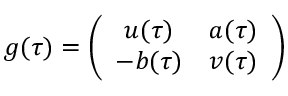<formula> <loc_0><loc_0><loc_500><loc_500>g ( \tau ) = \left ( \begin{array} { c c } { u ( \tau ) } & { a ( \tau ) } \\ { - b ( \tau ) } & { v ( \tau ) } \end{array} \right )</formula> 